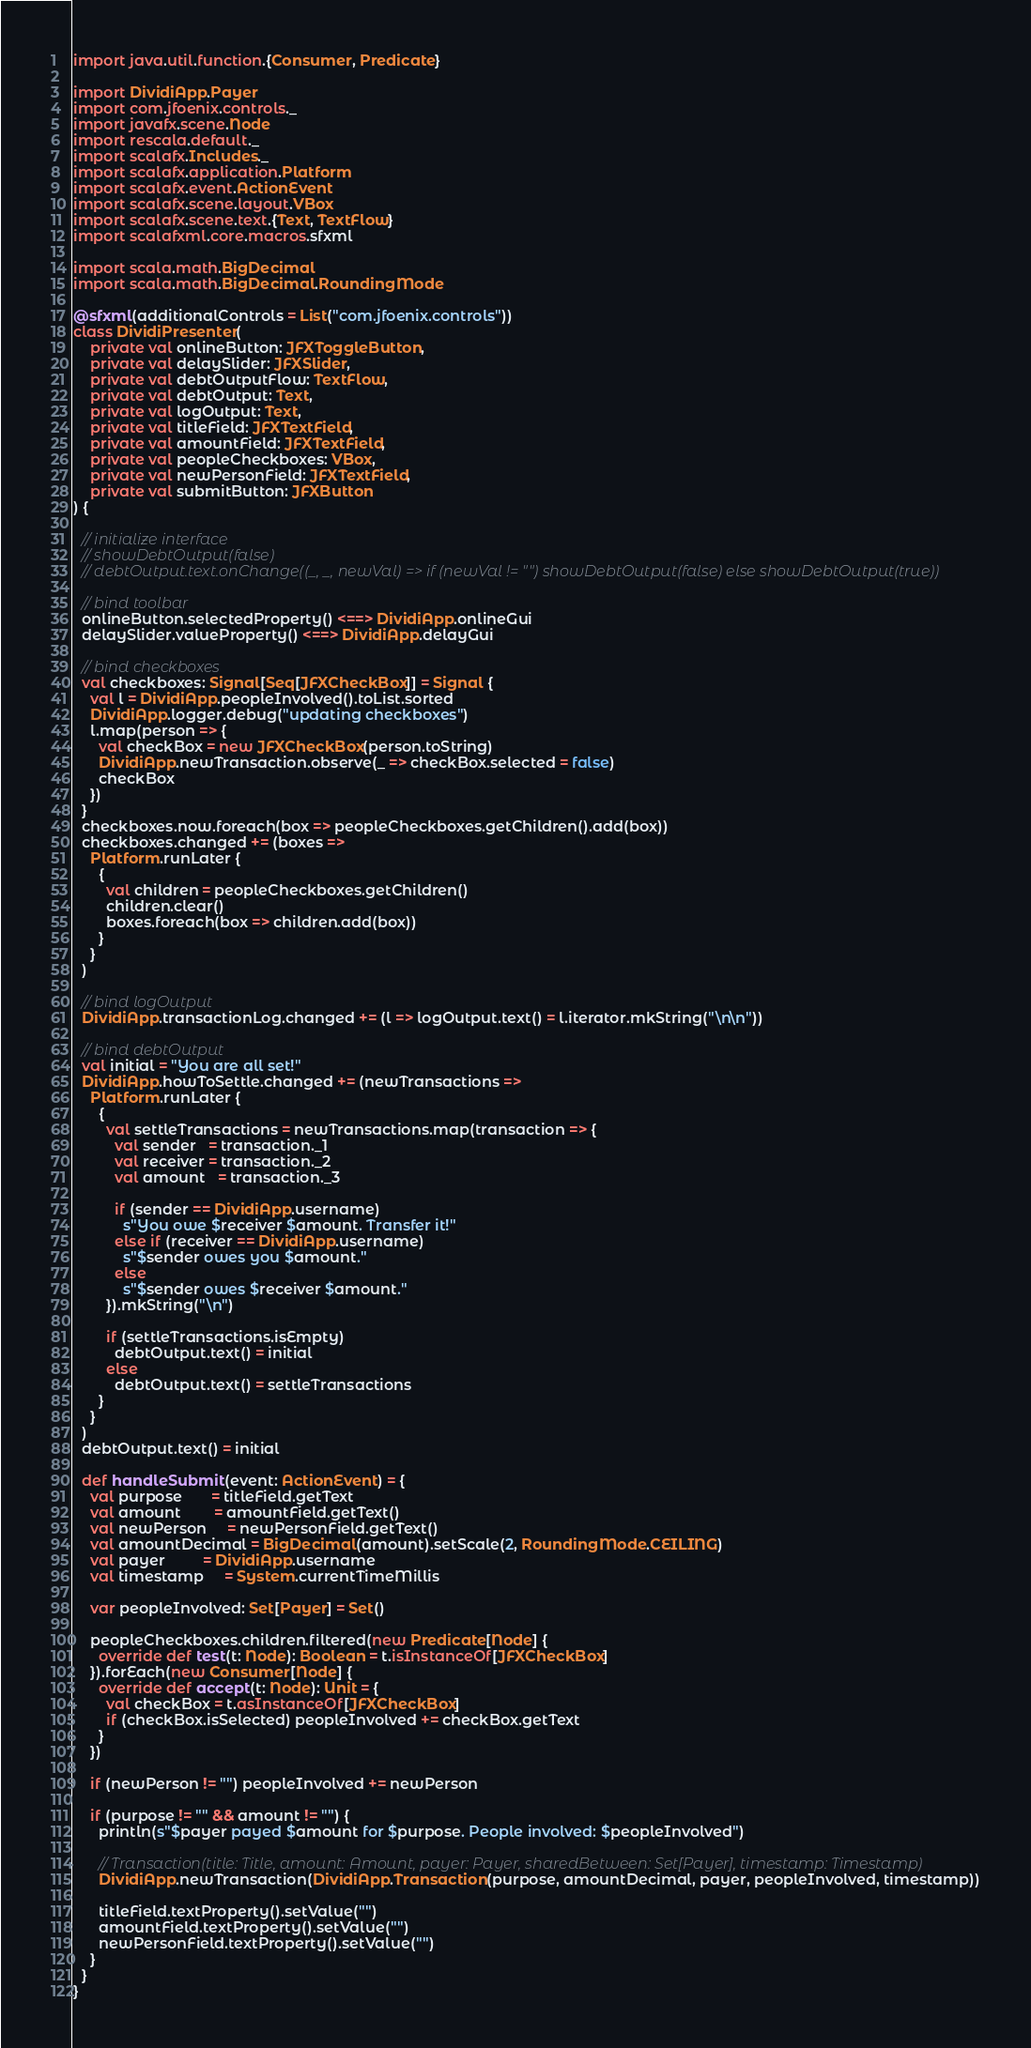<code> <loc_0><loc_0><loc_500><loc_500><_Scala_>import java.util.function.{Consumer, Predicate}

import DividiApp.Payer
import com.jfoenix.controls._
import javafx.scene.Node
import rescala.default._
import scalafx.Includes._
import scalafx.application.Platform
import scalafx.event.ActionEvent
import scalafx.scene.layout.VBox
import scalafx.scene.text.{Text, TextFlow}
import scalafxml.core.macros.sfxml

import scala.math.BigDecimal
import scala.math.BigDecimal.RoundingMode

@sfxml(additionalControls = List("com.jfoenix.controls"))
class DividiPresenter(
    private val onlineButton: JFXToggleButton,
    private val delaySlider: JFXSlider,
    private val debtOutputFlow: TextFlow,
    private val debtOutput: Text,
    private val logOutput: Text,
    private val titleField: JFXTextField,
    private val amountField: JFXTextField,
    private val peopleCheckboxes: VBox,
    private val newPersonField: JFXTextField,
    private val submitButton: JFXButton
) {

  // initialize interface
  // showDebtOutput(false)
  // debtOutput.text.onChange((_, _, newVal) => if (newVal != "") showDebtOutput(false) else showDebtOutput(true))

  // bind toolbar
  onlineButton.selectedProperty() <==> DividiApp.onlineGui
  delaySlider.valueProperty() <==> DividiApp.delayGui

  // bind checkboxes
  val checkboxes: Signal[Seq[JFXCheckBox]] = Signal {
    val l = DividiApp.peopleInvolved().toList.sorted
    DividiApp.logger.debug("updating checkboxes")
    l.map(person => {
      val checkBox = new JFXCheckBox(person.toString)
      DividiApp.newTransaction.observe(_ => checkBox.selected = false)
      checkBox
    })
  }
  checkboxes.now.foreach(box => peopleCheckboxes.getChildren().add(box))
  checkboxes.changed += (boxes =>
    Platform.runLater {
      {
        val children = peopleCheckboxes.getChildren()
        children.clear()
        boxes.foreach(box => children.add(box))
      }
    }
  )

  // bind logOutput
  DividiApp.transactionLog.changed += (l => logOutput.text() = l.iterator.mkString("\n\n"))

  // bind debtOutput
  val initial = "You are all set!"
  DividiApp.howToSettle.changed += (newTransactions =>
    Platform.runLater {
      {
        val settleTransactions = newTransactions.map(transaction => {
          val sender   = transaction._1
          val receiver = transaction._2
          val amount   = transaction._3

          if (sender == DividiApp.username)
            s"You owe $receiver $amount. Transfer it!"
          else if (receiver == DividiApp.username)
            s"$sender owes you $amount."
          else
            s"$sender owes $receiver $amount."
        }).mkString("\n")

        if (settleTransactions.isEmpty)
          debtOutput.text() = initial
        else
          debtOutput.text() = settleTransactions
      }
    }
  )
  debtOutput.text() = initial

  def handleSubmit(event: ActionEvent) = {
    val purpose       = titleField.getText
    val amount        = amountField.getText()
    val newPerson     = newPersonField.getText()
    val amountDecimal = BigDecimal(amount).setScale(2, RoundingMode.CEILING)
    val payer         = DividiApp.username
    val timestamp     = System.currentTimeMillis

    var peopleInvolved: Set[Payer] = Set()

    peopleCheckboxes.children.filtered(new Predicate[Node] {
      override def test(t: Node): Boolean = t.isInstanceOf[JFXCheckBox]
    }).forEach(new Consumer[Node] {
      override def accept(t: Node): Unit = {
        val checkBox = t.asInstanceOf[JFXCheckBox]
        if (checkBox.isSelected) peopleInvolved += checkBox.getText
      }
    })

    if (newPerson != "") peopleInvolved += newPerson

    if (purpose != "" && amount != "") {
      println(s"$payer payed $amount for $purpose. People involved: $peopleInvolved")

      // Transaction(title: Title, amount: Amount, payer: Payer, sharedBetween: Set[Payer], timestamp: Timestamp)
      DividiApp.newTransaction(DividiApp.Transaction(purpose, amountDecimal, payer, peopleInvolved, timestamp))

      titleField.textProperty().setValue("")
      amountField.textProperty().setValue("")
      newPersonField.textProperty().setValue("")
    }
  }
}
</code> 